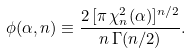<formula> <loc_0><loc_0><loc_500><loc_500>\phi ( \alpha , n ) \equiv \frac { 2 \, [ \pi \, \chi ^ { 2 } _ { n } ( \alpha ) ] ^ { n / 2 } } { n \, \Gamma ( n / 2 ) } .</formula> 